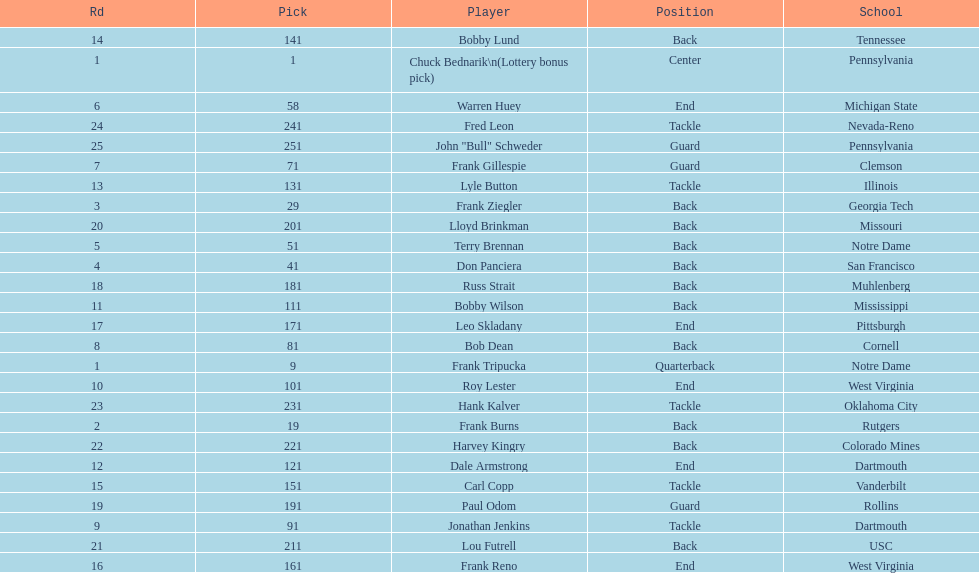Who was picked after frank burns? Frank Ziegler. 